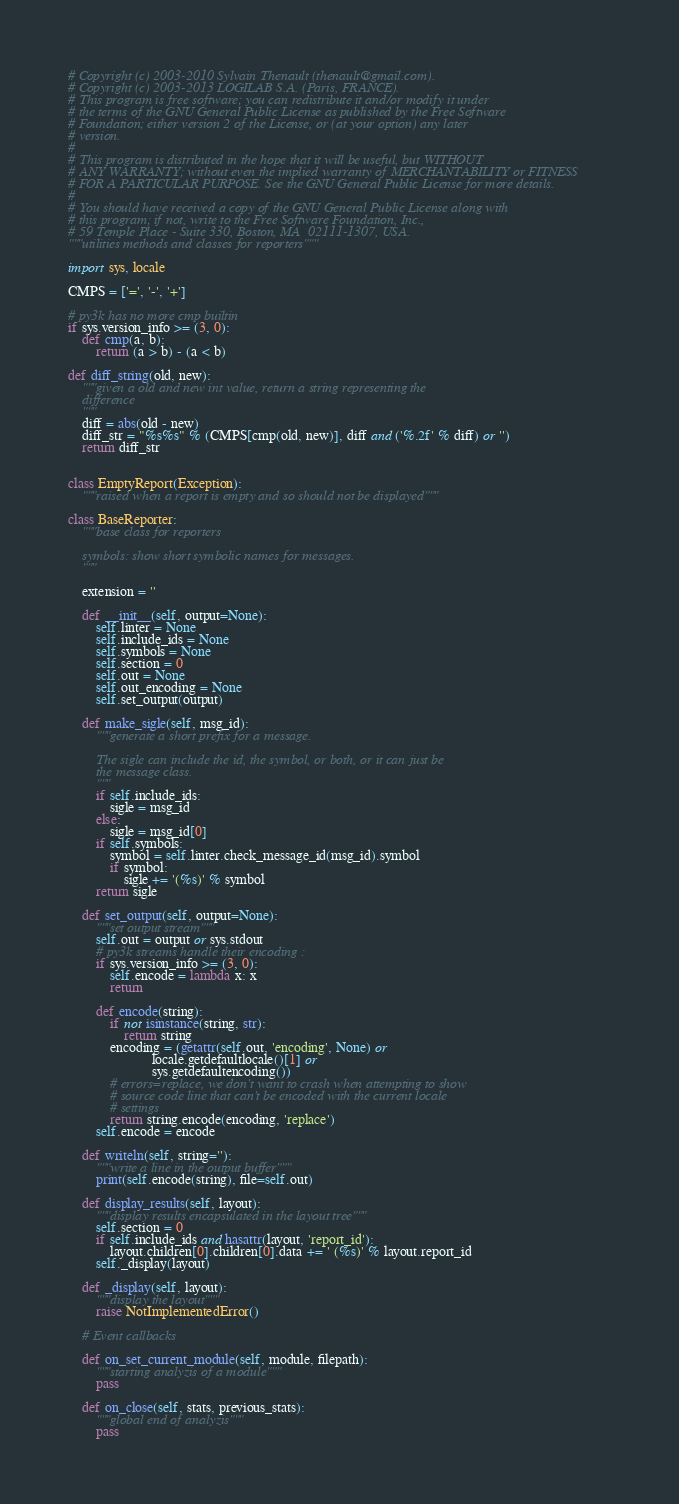Convert code to text. <code><loc_0><loc_0><loc_500><loc_500><_Python_># Copyright (c) 2003-2010 Sylvain Thenault (thenault@gmail.com).
# Copyright (c) 2003-2013 LOGILAB S.A. (Paris, FRANCE).
# This program is free software; you can redistribute it and/or modify it under
# the terms of the GNU General Public License as published by the Free Software
# Foundation; either version 2 of the License, or (at your option) any later
# version.
#
# This program is distributed in the hope that it will be useful, but WITHOUT
# ANY WARRANTY; without even the implied warranty of MERCHANTABILITY or FITNESS
# FOR A PARTICULAR PURPOSE. See the GNU General Public License for more details.
#
# You should have received a copy of the GNU General Public License along with
# this program; if not, write to the Free Software Foundation, Inc.,
# 59 Temple Place - Suite 330, Boston, MA  02111-1307, USA.
"""utilities methods and classes for reporters"""

import sys, locale

CMPS = ['=', '-', '+']

# py3k has no more cmp builtin
if sys.version_info >= (3, 0):
    def cmp(a, b):
        return (a > b) - (a < b)

def diff_string(old, new):
    """given a old and new int value, return a string representing the
    difference
    """
    diff = abs(old - new)
    diff_str = "%s%s" % (CMPS[cmp(old, new)], diff and ('%.2f' % diff) or '')
    return diff_str


class EmptyReport(Exception):
    """raised when a report is empty and so should not be displayed"""

class BaseReporter:
    """base class for reporters

    symbols: show short symbolic names for messages.
    """

    extension = ''

    def __init__(self, output=None):
        self.linter = None
        self.include_ids = None
        self.symbols = None
        self.section = 0
        self.out = None
        self.out_encoding = None
        self.set_output(output)

    def make_sigle(self, msg_id):
        """generate a short prefix for a message.

        The sigle can include the id, the symbol, or both, or it can just be
        the message class.
        """
        if self.include_ids:
            sigle = msg_id
        else:
            sigle = msg_id[0]
        if self.symbols:
            symbol = self.linter.check_message_id(msg_id).symbol
            if symbol:
                sigle += '(%s)' % symbol
        return sigle

    def set_output(self, output=None):
        """set output stream"""
        self.out = output or sys.stdout
        # py3k streams handle their encoding :
        if sys.version_info >= (3, 0):
            self.encode = lambda x: x
            return

        def encode(string):
            if not isinstance(string, str):
                return string
            encoding = (getattr(self.out, 'encoding', None) or
                        locale.getdefaultlocale()[1] or
                        sys.getdefaultencoding())
            # errors=replace, we don't want to crash when attempting to show
            # source code line that can't be encoded with the current locale
            # settings
            return string.encode(encoding, 'replace')
        self.encode = encode

    def writeln(self, string=''):
        """write a line in the output buffer"""
        print(self.encode(string), file=self.out)

    def display_results(self, layout):
        """display results encapsulated in the layout tree"""
        self.section = 0
        if self.include_ids and hasattr(layout, 'report_id'):
            layout.children[0].children[0].data += ' (%s)' % layout.report_id
        self._display(layout)

    def _display(self, layout):
        """display the layout"""
        raise NotImplementedError()

    # Event callbacks

    def on_set_current_module(self, module, filepath):
        """starting analyzis of a module"""
        pass

    def on_close(self, stats, previous_stats):
        """global end of analyzis"""
        pass


</code> 